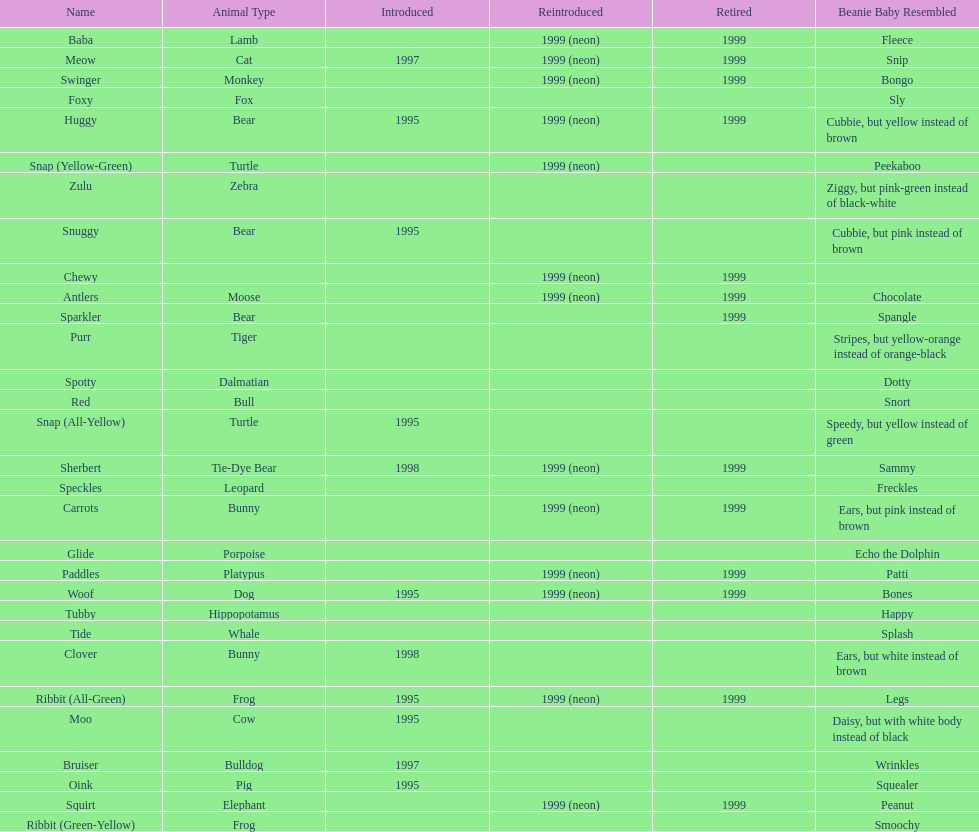What is the name of the last pillow pal on this chart? Zulu. 